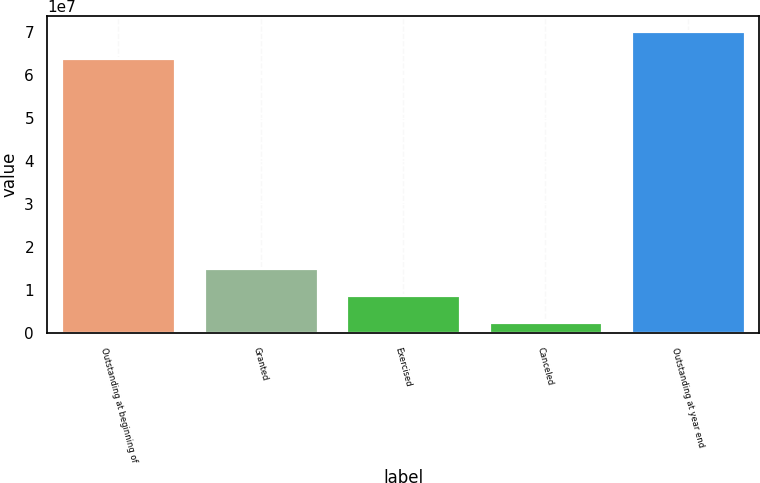Convert chart to OTSL. <chart><loc_0><loc_0><loc_500><loc_500><bar_chart><fcel>Outstanding at beginning of<fcel>Granted<fcel>Exercised<fcel>Canceled<fcel>Outstanding at year end<nl><fcel>6.39388e+07<fcel>1.52309e+07<fcel>8.98132e+06<fcel>2.73174e+06<fcel>7.01884e+07<nl></chart> 